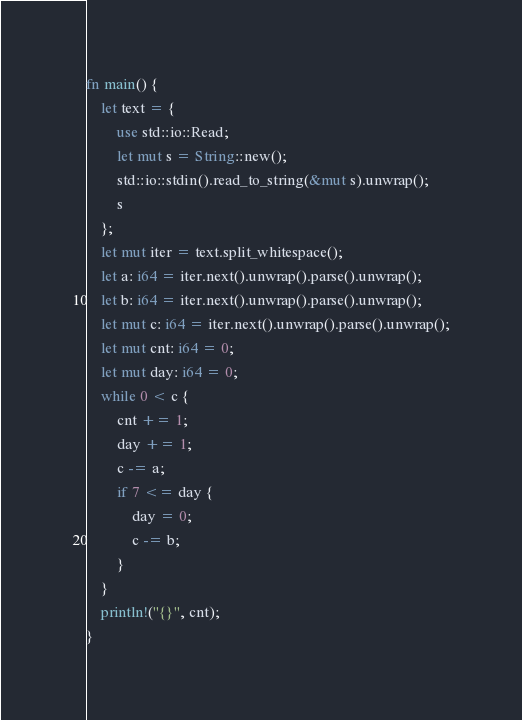Convert code to text. <code><loc_0><loc_0><loc_500><loc_500><_Rust_>fn main() {
	let text = {
		use std::io::Read;
		let mut s = String::new();
		std::io::stdin().read_to_string(&mut s).unwrap();
		s
	};
	let mut iter = text.split_whitespace();
	let a: i64 = iter.next().unwrap().parse().unwrap();
	let b: i64 = iter.next().unwrap().parse().unwrap();
	let mut c: i64 = iter.next().unwrap().parse().unwrap();
	let mut cnt: i64 = 0;
	let mut day: i64 = 0;
	while 0 < c {
		cnt += 1;
		day += 1;
		c -= a;
		if 7 <= day {
			day = 0;
			c -= b;
		}
	}
	println!("{}", cnt);
}

</code> 